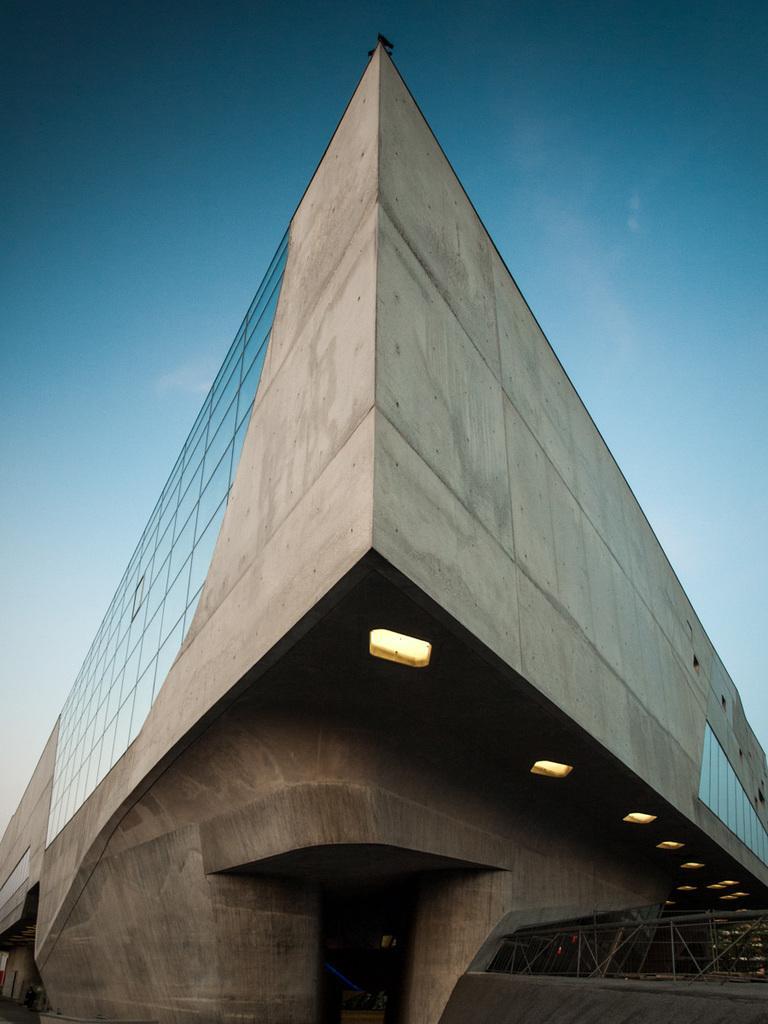How would you summarize this image in a sentence or two? In this picture we can see a building. There is a glass and a few lights on the building. 